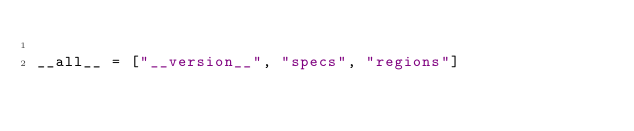Convert code to text. <code><loc_0><loc_0><loc_500><loc_500><_Python_>
__all__ = ["__version__", "specs", "regions"]
</code> 